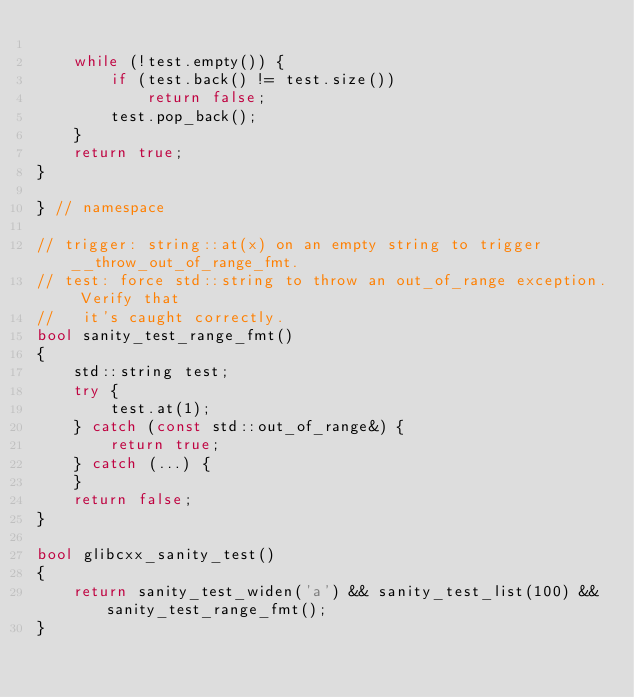<code> <loc_0><loc_0><loc_500><loc_500><_C++_>
    while (!test.empty()) {
        if (test.back() != test.size())
            return false;
        test.pop_back();
    }
    return true;
}

} // namespace

// trigger: string::at(x) on an empty string to trigger __throw_out_of_range_fmt.
// test: force std::string to throw an out_of_range exception. Verify that
//   it's caught correctly.
bool sanity_test_range_fmt()
{
    std::string test;
    try {
        test.at(1);
    } catch (const std::out_of_range&) {
        return true;
    } catch (...) {
    }
    return false;
}

bool glibcxx_sanity_test()
{
    return sanity_test_widen('a') && sanity_test_list(100) && sanity_test_range_fmt();
}
</code> 